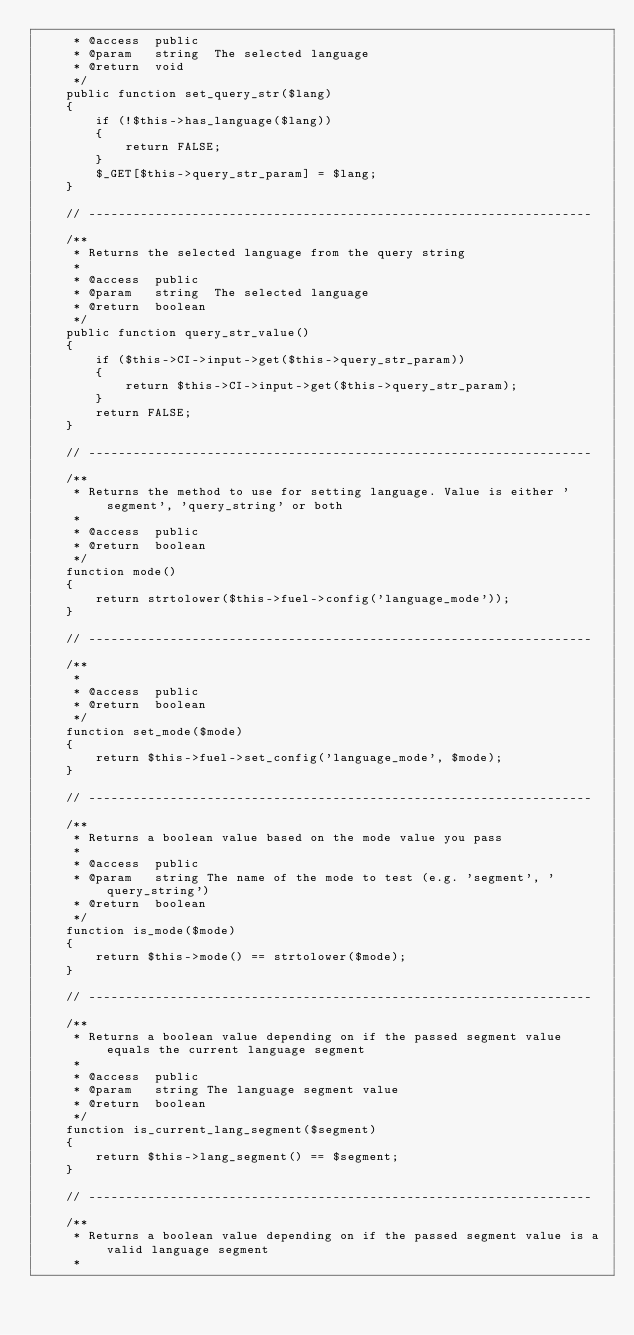Convert code to text. <code><loc_0><loc_0><loc_500><loc_500><_PHP_>	 * @access	public
	 * @param	string	The selected language 
	 * @return	void
	 */	
	public function set_query_str($lang)
	{
		if (!$this->has_language($lang))
		{
			return FALSE;
		}
		$_GET[$this->query_str_param] = $lang;
	}
	
	// --------------------------------------------------------------------
	
	/**
	 * Returns the selected language from the query string
	 *
	 * @access	public
	 * @param	string	The selected language 
	 * @return	boolean
	 */	
	public function query_str_value()
	{
		if ($this->CI->input->get($this->query_str_param))
		{
			return $this->CI->input->get($this->query_str_param);
		}
		return FALSE;
	}
	
	// --------------------------------------------------------------------
	
	/**
	 * Returns the method to use for setting language. Value is either 'segment', 'query_string' or both
	 *
	 * @access	public
	 * @return	boolean
	 */
	function mode()
	{
		return strtolower($this->fuel->config('language_mode'));
	}

	// --------------------------------------------------------------------
	
	/**
	 *
	 * @access	public
	 * @return	boolean
	 */
	function set_mode($mode)
	{
		return $this->fuel->set_config('language_mode', $mode);
	}
	
	// --------------------------------------------------------------------
	
	/**
	 * Returns a boolean value based on the mode value you pass
	 *
	 * @access	public
	 * @param	string The name of the mode to test (e.g. 'segment', 'query_string')
	 * @return	boolean
	 */
	function is_mode($mode)
	{
		return $this->mode() == strtolower($mode);
	}

	// --------------------------------------------------------------------
	
	/**
	 * Returns a boolean value depending on if the passed segment value equals the current language segment
	 *
	 * @access	public
	 * @param	string The language segment value
	 * @return	boolean
	 */
	function is_current_lang_segment($segment)
	{
		return $this->lang_segment() == $segment;
	}

	// --------------------------------------------------------------------
	
	/**
	 * Returns a boolean value depending on if the passed segment value is a valid language segment
	 *</code> 